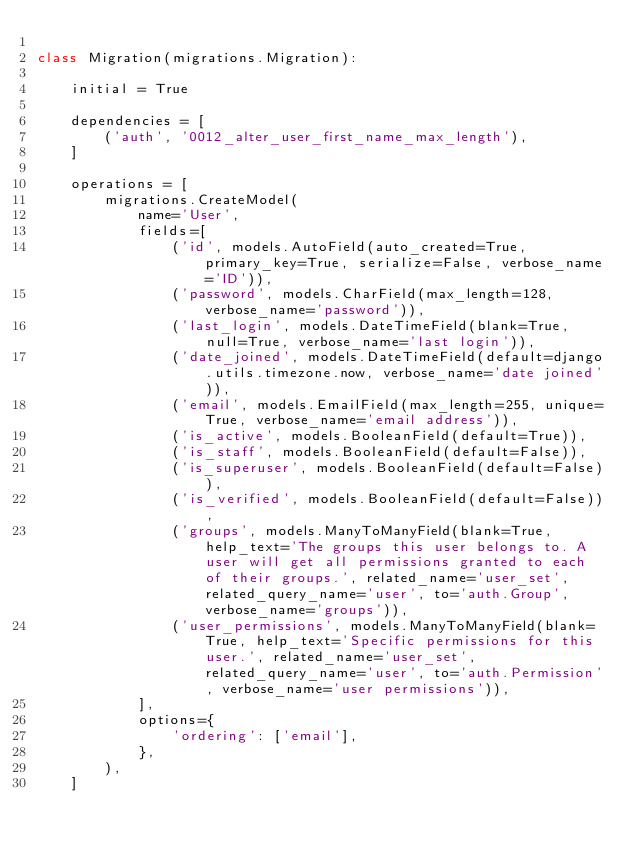<code> <loc_0><loc_0><loc_500><loc_500><_Python_>
class Migration(migrations.Migration):

    initial = True

    dependencies = [
        ('auth', '0012_alter_user_first_name_max_length'),
    ]

    operations = [
        migrations.CreateModel(
            name='User',
            fields=[
                ('id', models.AutoField(auto_created=True, primary_key=True, serialize=False, verbose_name='ID')),
                ('password', models.CharField(max_length=128, verbose_name='password')),
                ('last_login', models.DateTimeField(blank=True, null=True, verbose_name='last login')),
                ('date_joined', models.DateTimeField(default=django.utils.timezone.now, verbose_name='date joined')),
                ('email', models.EmailField(max_length=255, unique=True, verbose_name='email address')),
                ('is_active', models.BooleanField(default=True)),
                ('is_staff', models.BooleanField(default=False)),
                ('is_superuser', models.BooleanField(default=False)),
                ('is_verified', models.BooleanField(default=False)),
                ('groups', models.ManyToManyField(blank=True, help_text='The groups this user belongs to. A user will get all permissions granted to each of their groups.', related_name='user_set', related_query_name='user', to='auth.Group', verbose_name='groups')),
                ('user_permissions', models.ManyToManyField(blank=True, help_text='Specific permissions for this user.', related_name='user_set', related_query_name='user', to='auth.Permission', verbose_name='user permissions')),
            ],
            options={
                'ordering': ['email'],
            },
        ),
    ]
</code> 